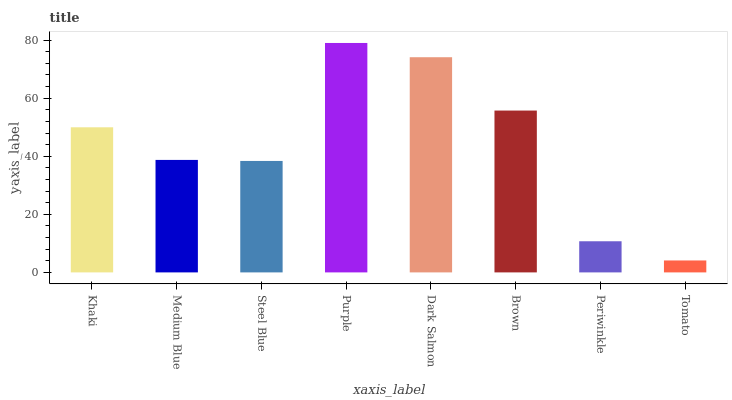Is Tomato the minimum?
Answer yes or no. Yes. Is Purple the maximum?
Answer yes or no. Yes. Is Medium Blue the minimum?
Answer yes or no. No. Is Medium Blue the maximum?
Answer yes or no. No. Is Khaki greater than Medium Blue?
Answer yes or no. Yes. Is Medium Blue less than Khaki?
Answer yes or no. Yes. Is Medium Blue greater than Khaki?
Answer yes or no. No. Is Khaki less than Medium Blue?
Answer yes or no. No. Is Khaki the high median?
Answer yes or no. Yes. Is Medium Blue the low median?
Answer yes or no. Yes. Is Periwinkle the high median?
Answer yes or no. No. Is Khaki the low median?
Answer yes or no. No. 